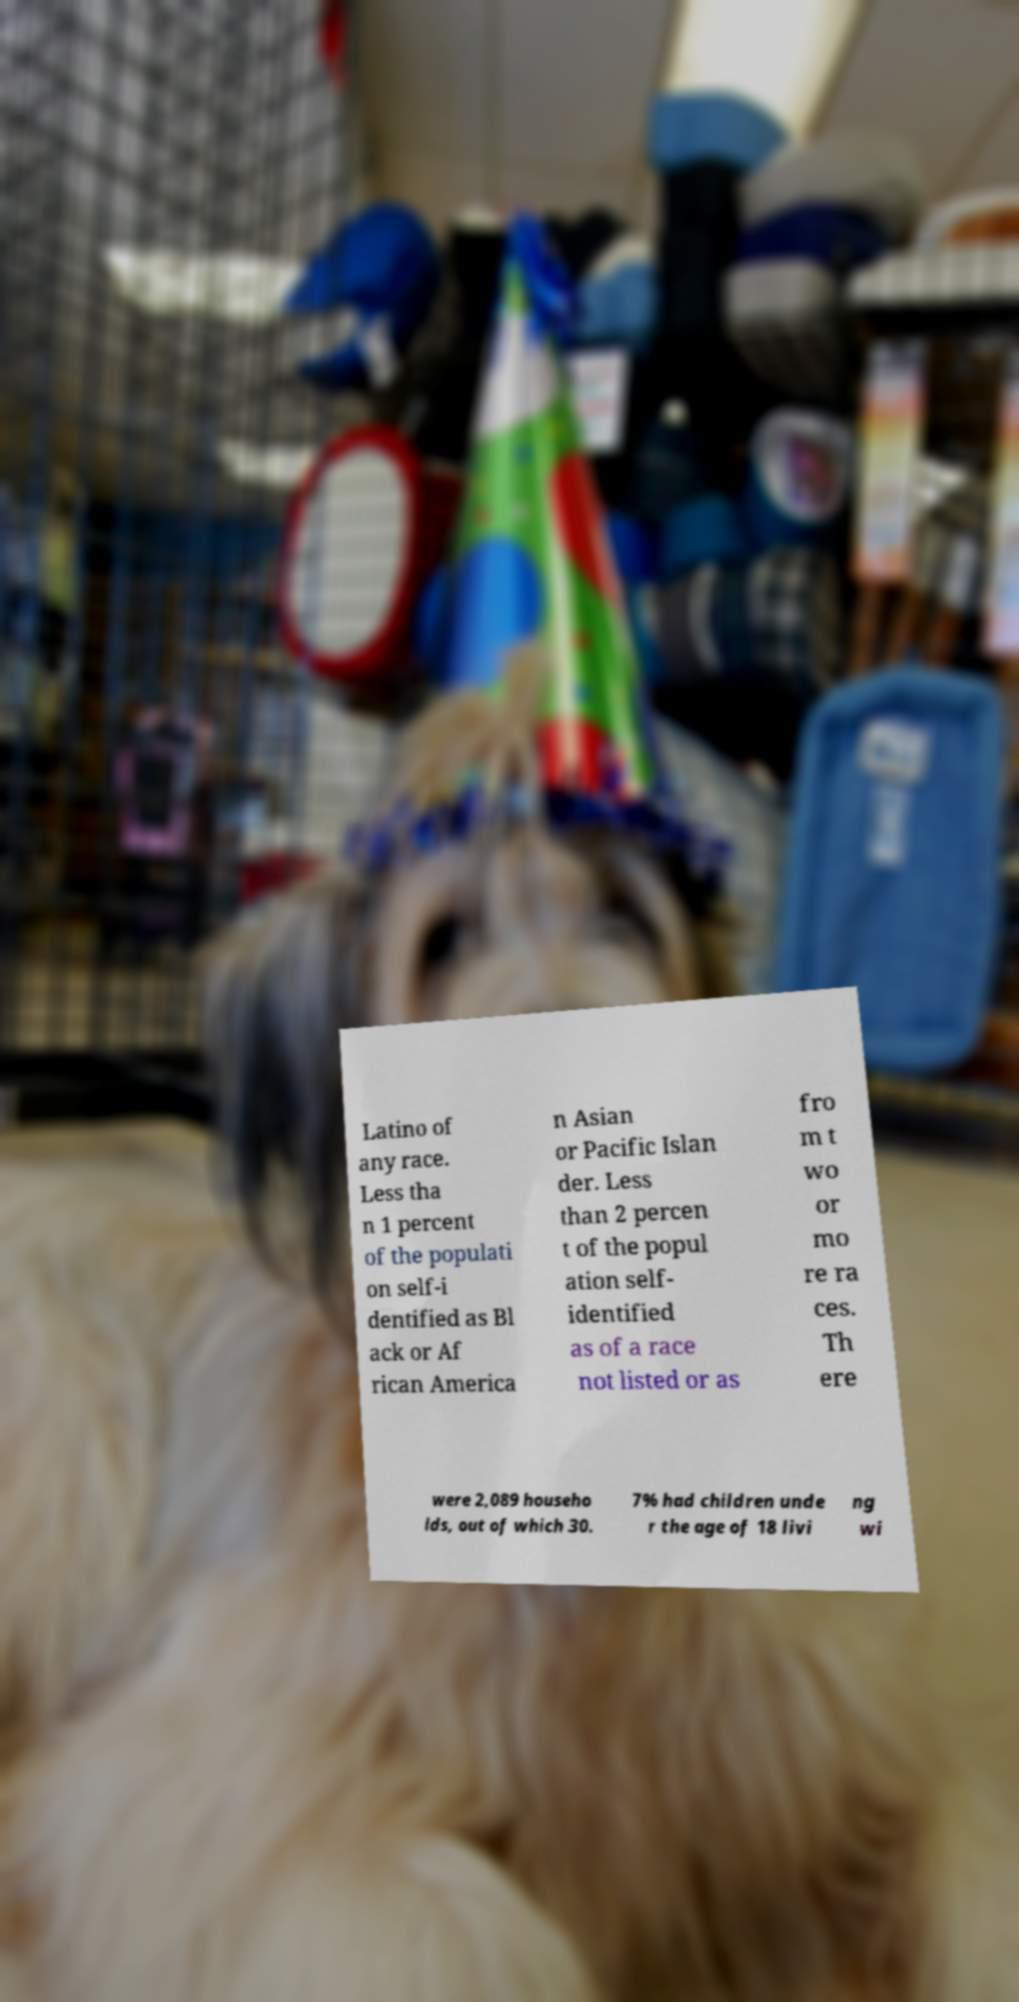Please identify and transcribe the text found in this image. Latino of any race. Less tha n 1 percent of the populati on self-i dentified as Bl ack or Af rican America n Asian or Pacific Islan der. Less than 2 percen t of the popul ation self- identified as of a race not listed or as fro m t wo or mo re ra ces. Th ere were 2,089 househo lds, out of which 30. 7% had children unde r the age of 18 livi ng wi 